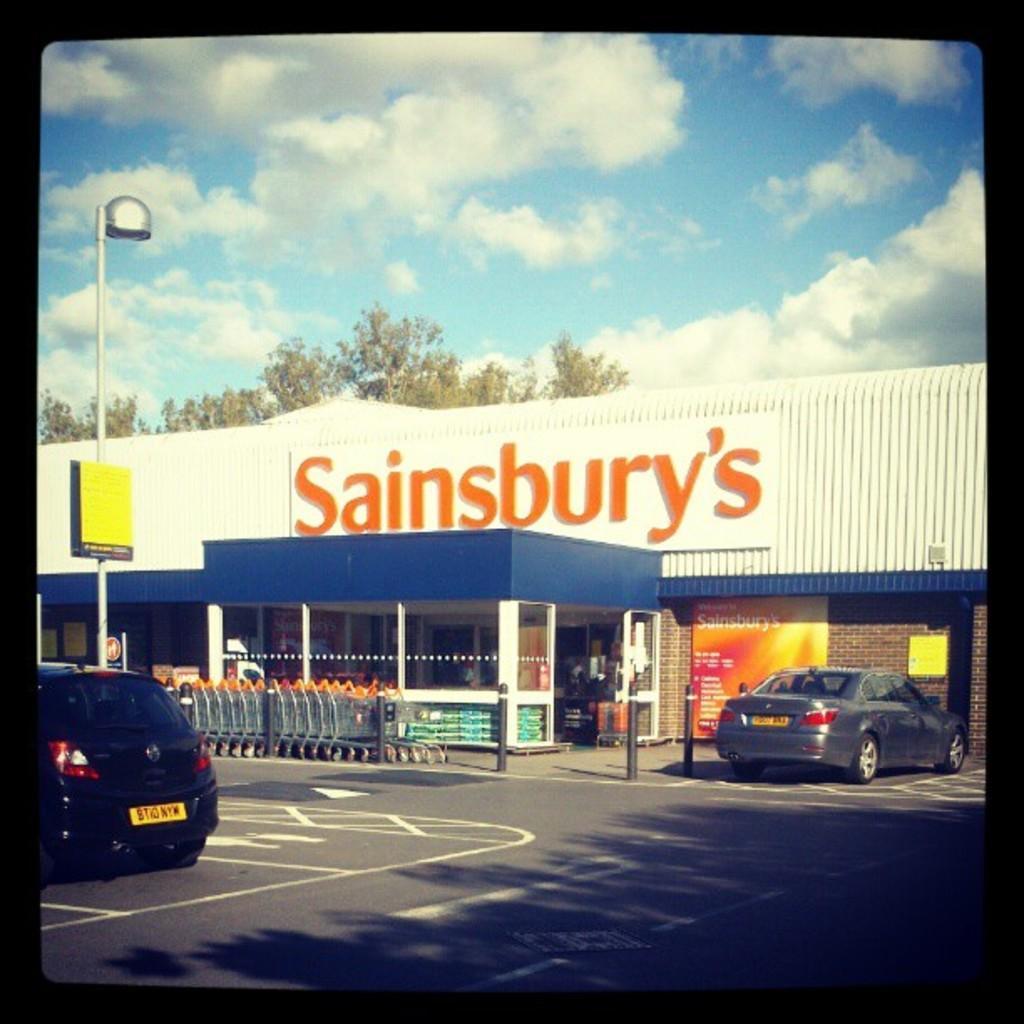Can you describe this image briefly? In the center of the image there is a building and we can see trolleys. At the bottom there is a road and we can see cars on the road. In the background there is a pole, trees and sky. 